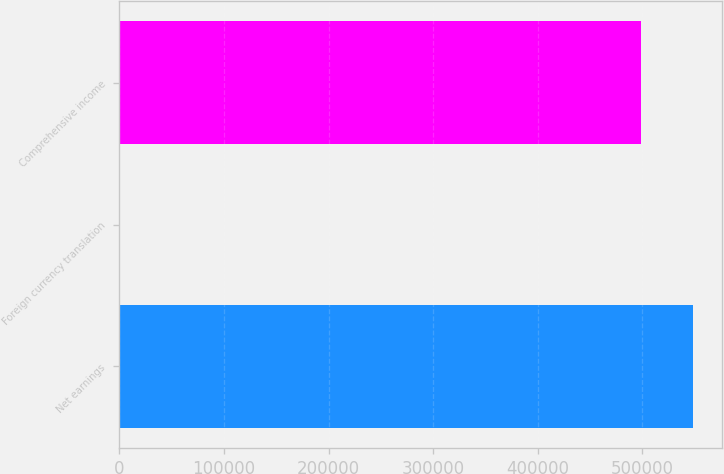Convert chart to OTSL. <chart><loc_0><loc_0><loc_500><loc_500><bar_chart><fcel>Net earnings<fcel>Foreign currency translation<fcel>Comprehensive income<nl><fcel>548435<fcel>901<fcel>498577<nl></chart> 